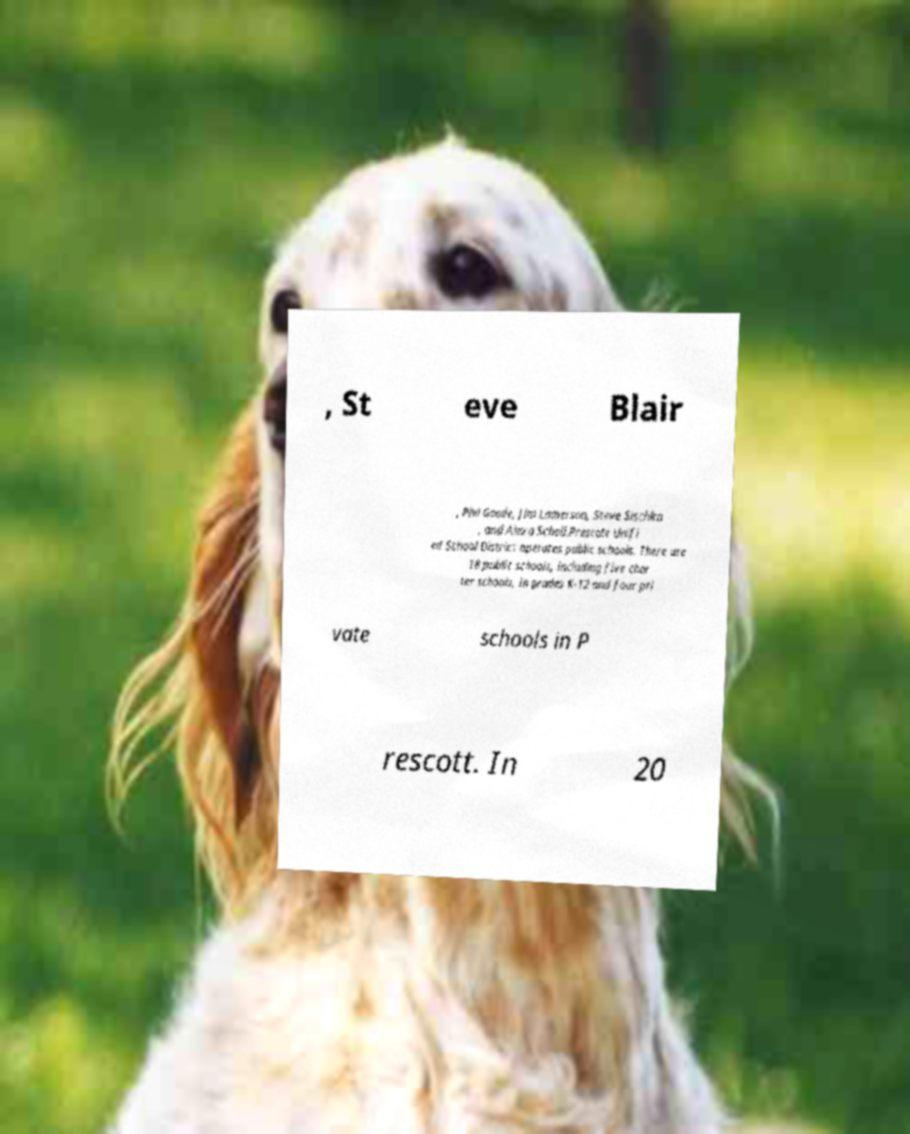Can you accurately transcribe the text from the provided image for me? , St eve Blair , Phil Goode, Jim Lamerson, Steve Sischka , and Alexa Scholl.Prescott Unifi ed School District operates public schools. There are 18 public schools, including five char ter schools, in grades K-12 and four pri vate schools in P rescott. In 20 